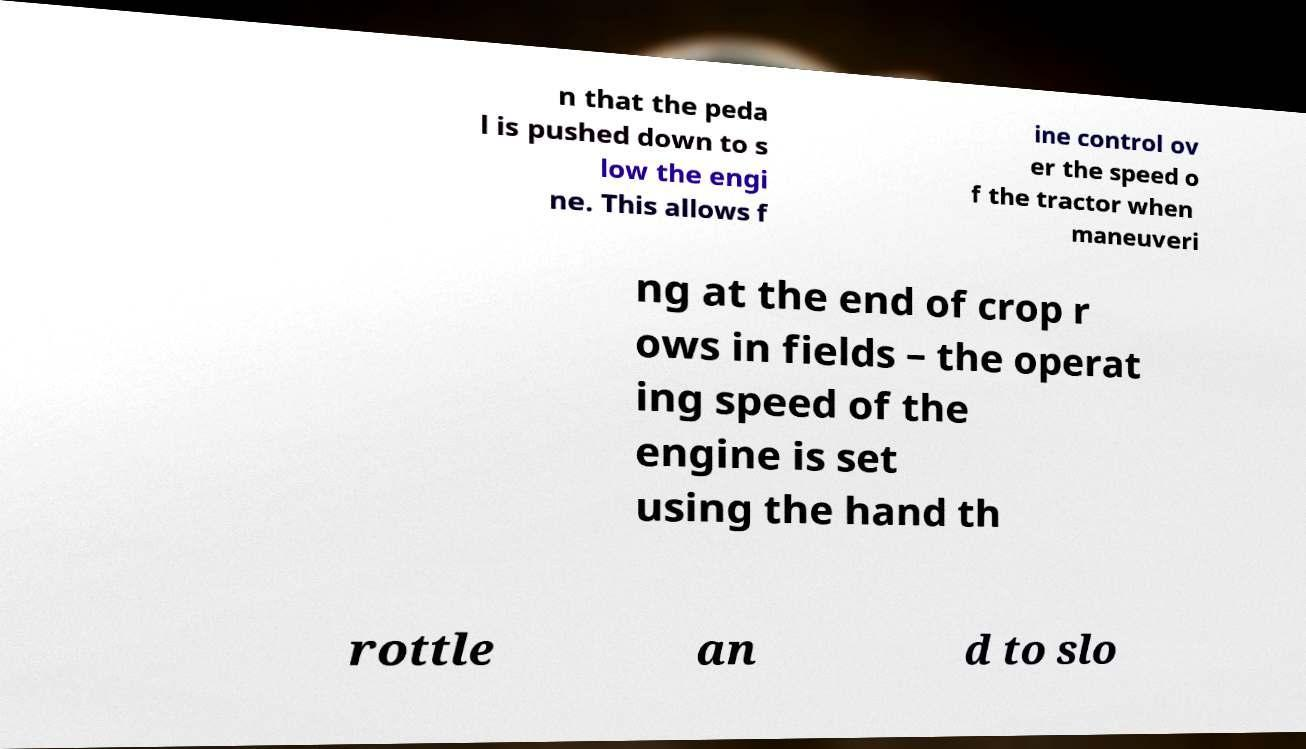What messages or text are displayed in this image? I need them in a readable, typed format. n that the peda l is pushed down to s low the engi ne. This allows f ine control ov er the speed o f the tractor when maneuveri ng at the end of crop r ows in fields – the operat ing speed of the engine is set using the hand th rottle an d to slo 